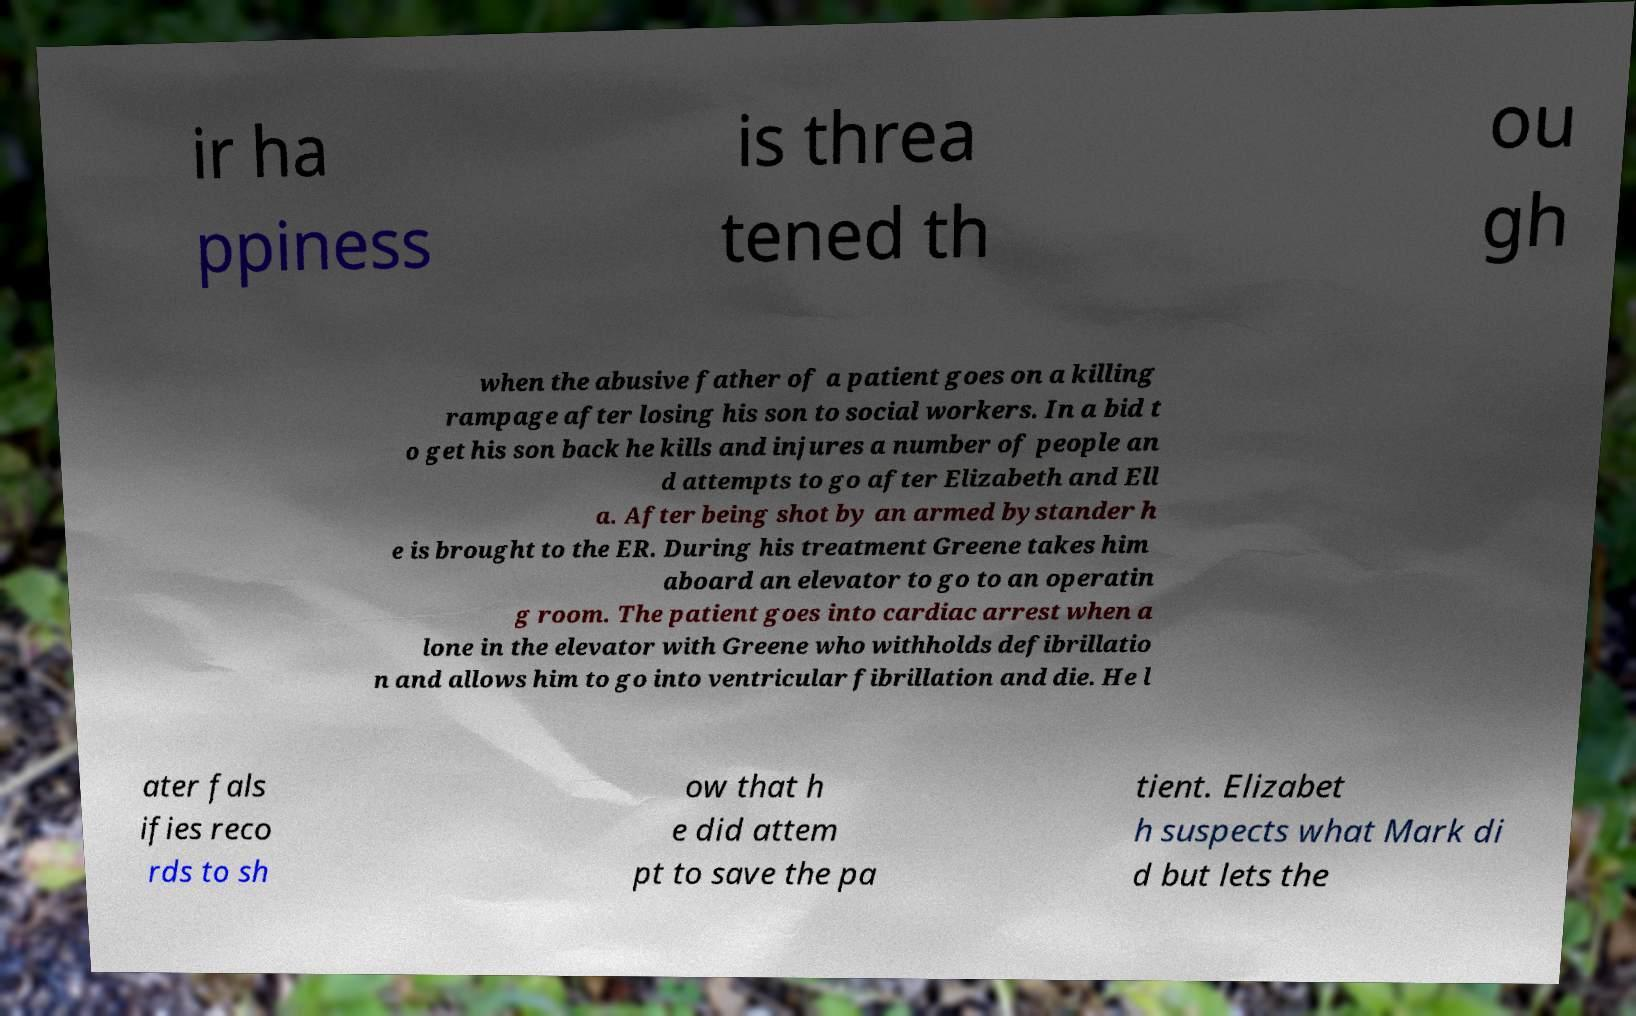Please read and relay the text visible in this image. What does it say? ir ha ppiness is threa tened th ou gh when the abusive father of a patient goes on a killing rampage after losing his son to social workers. In a bid t o get his son back he kills and injures a number of people an d attempts to go after Elizabeth and Ell a. After being shot by an armed bystander h e is brought to the ER. During his treatment Greene takes him aboard an elevator to go to an operatin g room. The patient goes into cardiac arrest when a lone in the elevator with Greene who withholds defibrillatio n and allows him to go into ventricular fibrillation and die. He l ater fals ifies reco rds to sh ow that h e did attem pt to save the pa tient. Elizabet h suspects what Mark di d but lets the 